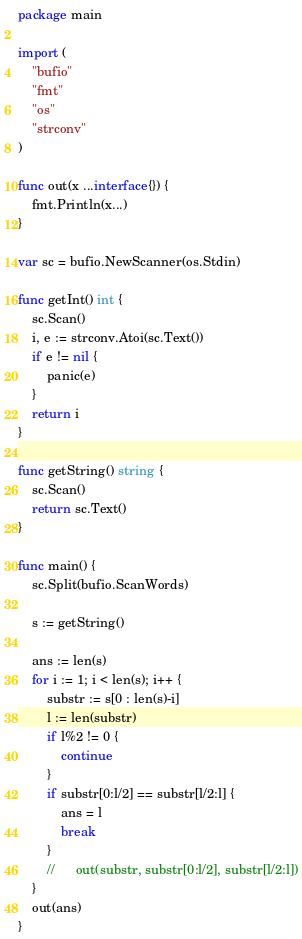<code> <loc_0><loc_0><loc_500><loc_500><_Go_>package main

import (
	"bufio"
	"fmt"
	"os"
	"strconv"
)

func out(x ...interface{}) {
	fmt.Println(x...)
}

var sc = bufio.NewScanner(os.Stdin)

func getInt() int {
	sc.Scan()
	i, e := strconv.Atoi(sc.Text())
	if e != nil {
		panic(e)
	}
	return i
}

func getString() string {
	sc.Scan()
	return sc.Text()
}

func main() {
	sc.Split(bufio.ScanWords)

	s := getString()

	ans := len(s)
	for i := 1; i < len(s); i++ {
		substr := s[0 : len(s)-i]
		l := len(substr)
		if l%2 != 0 {
			continue
		}
		if substr[0:l/2] == substr[l/2:l] {
			ans = l
			break
		}
		//		out(substr, substr[0:l/2], substr[l/2:l])
	}
	out(ans)
}
</code> 